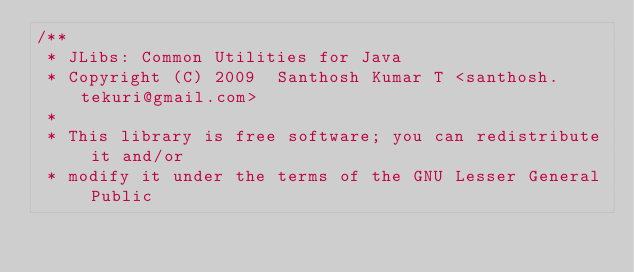<code> <loc_0><loc_0><loc_500><loc_500><_Java_>/**
 * JLibs: Common Utilities for Java
 * Copyright (C) 2009  Santhosh Kumar T <santhosh.tekuri@gmail.com>
 *
 * This library is free software; you can redistribute it and/or
 * modify it under the terms of the GNU Lesser General Public</code> 